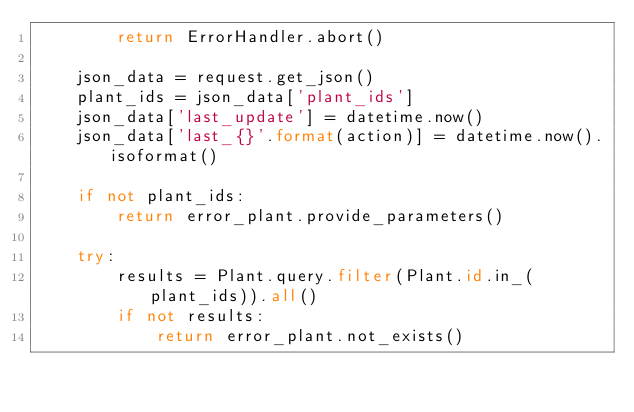<code> <loc_0><loc_0><loc_500><loc_500><_Python_>        return ErrorHandler.abort()

    json_data = request.get_json()
    plant_ids = json_data['plant_ids']
    json_data['last_update'] = datetime.now()
    json_data['last_{}'.format(action)] = datetime.now().isoformat()

    if not plant_ids:
        return error_plant.provide_parameters()

    try:
        results = Plant.query.filter(Plant.id.in_(plant_ids)).all()
        if not results:
            return error_plant.not_exists()</code> 